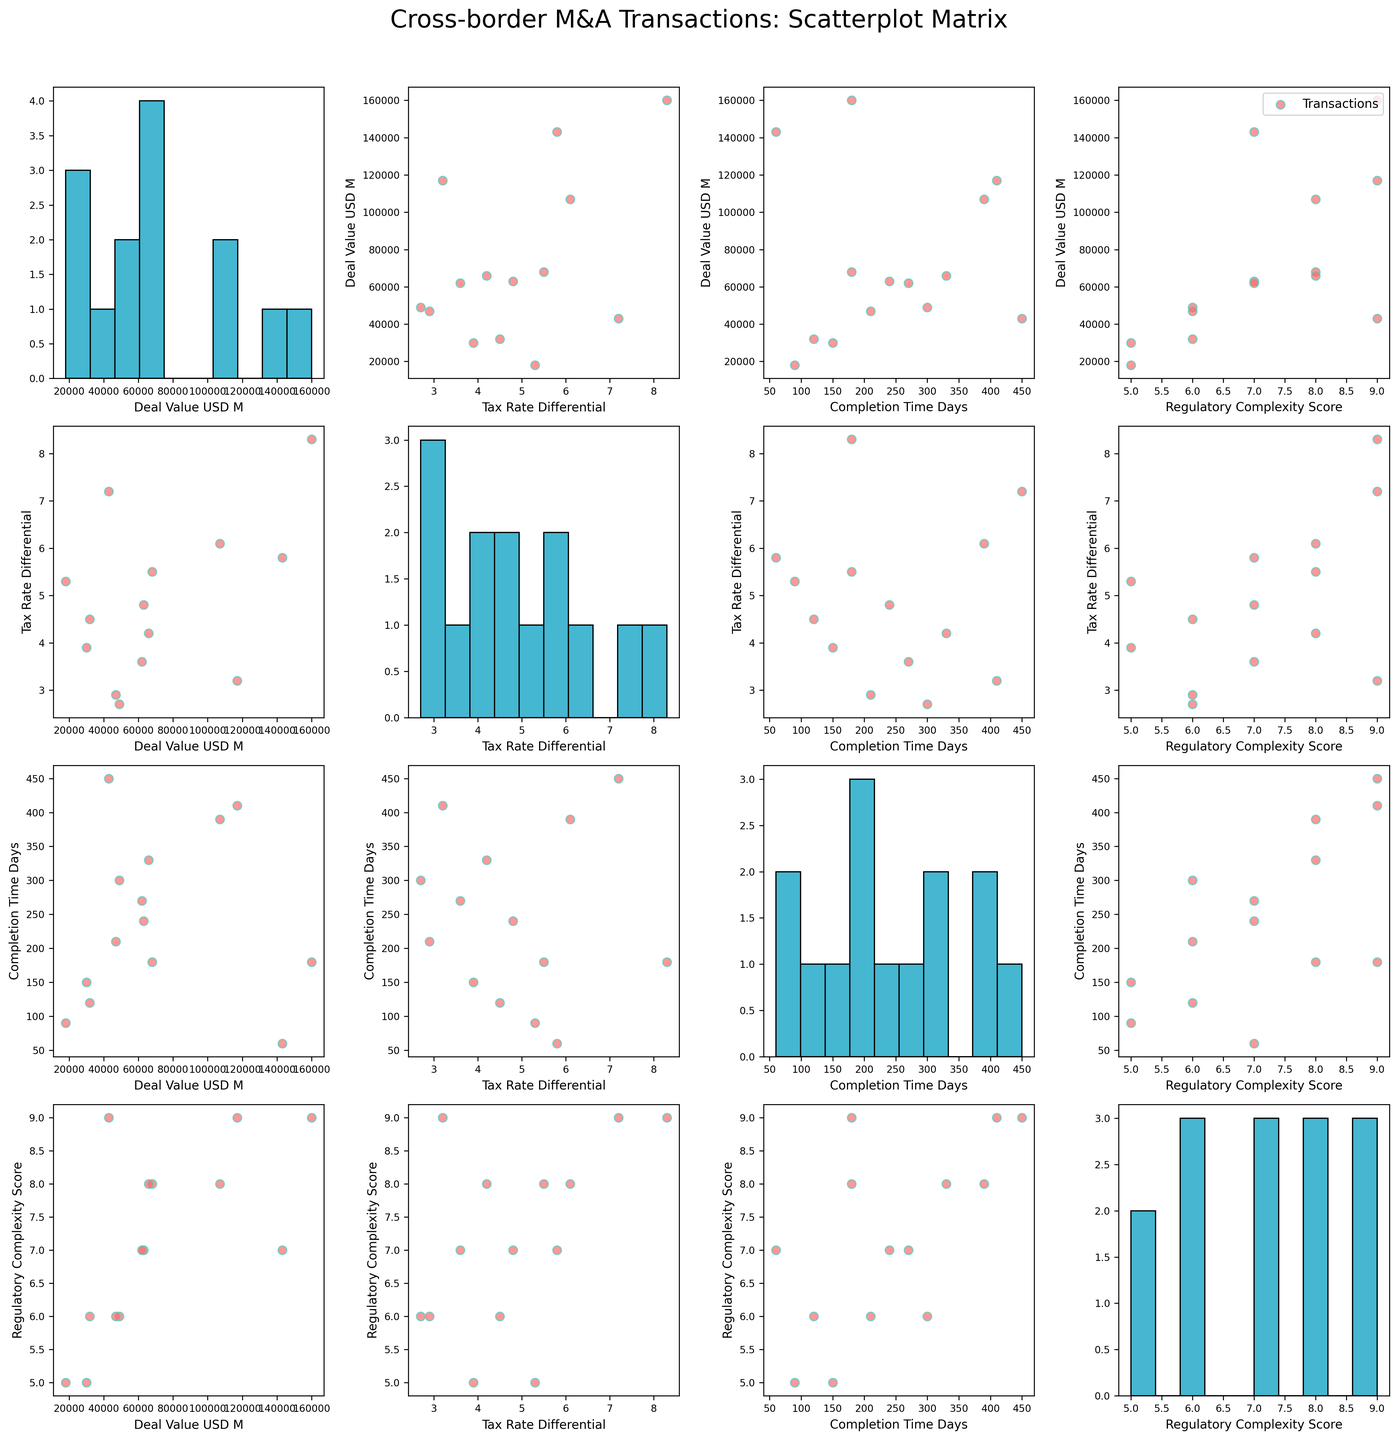How many data points are displayed in the scatterplot matrix? By observing any of the scatter plots in the matrix, we can count the number of points plotted. Each point represents a unique transaction, and there are 14 transactions listed in the data provided.
Answer: 14 Which variable is plotted along the horizontal axis in the first scatter plot in the top row? In the first scatter plot in the top row, which is the second column of the matrix, the horizontal axis variable is "Tax Rate Differential." This can be observed by looking at the label along the x-axis.
Answer: Tax Rate Differential What is the highest value of "Deal Value USD M" as seen in the histograms on the diagonal? To find the highest deal value, observe the histogram plotted in the first diagonal cell. The highest bin stretches to the range that includes 160,000.
Answer: 160,000 Is there a visible relationship between "Deal Value USD M" and "Completion Time Days"? By observing the scatter plot where "Deal Value USD M" is on the y-axis and "Completion Time Days" is on the x-axis (first row, third column), we can determine if there is any visible trend or correlation. The points appear randomly scattered, indicating no clear relationship.
Answer: No clear relationship Are transactions with higher "Regulatory Complexity Score" more likely to have longer "Completion Time Days"? Check the scatter plot where "Regulatory Complexity Score" is on the x-axis and "Completion Time Days" is on the y-axis (fourth row, third column). Points in general trend upwards from left to right, implying that higher complexity might correlate with longer completion times.
Answer: Yes, likely What is the average "Tax Rate Differential" across the transactions? Observe the histogram for "Tax Rate Differential" values (second diagonal cell) and estimate the average from the distribution. Alternatively, calculate the average by summing up the values and dividing by the number of transactions. Based on the provided data, (5.5 + 3.2 + 4.8 + 2.7 + 6.1 + 3.9 + 7.2 + 4.5 + 5.8 + 8.3 + 3.6 + 4.2 + 2.9 + 5.3)/14 ≈ 4.9
Answer: 4.9 Which transaction has the smallest "Deal Value USD M" and how is it represented in the scatterplot matrix? Observing the histogram in the first diagonal cell or the data, the transaction "Randgold Resources-Barrick Gold" has the smallest deal value of 18,000. This point will appear in the scatter plots involving "Deal Value USD M" as the lowest point.
Answer: Randgold Resources-Barrick Gold, 18,000 Do any of the scatter plots show a clear linear correlation? To identify clear linear correlations, look for scatter plots with points forming a straight line pattern. The scatter plot between "Regulatory Complexity Score" and "Completion Time Days" (fourth row, third column) might suggest a potential linear relationship.
Answer: The plot between "Regulatory Complexity Score" and "Completion Time Days" shows a potential linear correlation What is the range of "Completion Time Days" covered in the scatterplot matrix? By observing the histogram in the third diagonal cell, the data spans from a minimum of 60 to a maximum around 450 days.
Answer: 60 to 450 Which transaction has the highest "Tax Rate Differential" and where would it appear in relevant scatter plots? According to the data, the "Allergan-Pfizer" transaction has the highest tax rate differential of 8.3. In scatter plots involving "Tax Rate Differential," this transaction will appear as the highest point along the Tax Rate Differential axis.
Answer: Allergan-Pfizer, 8.3 